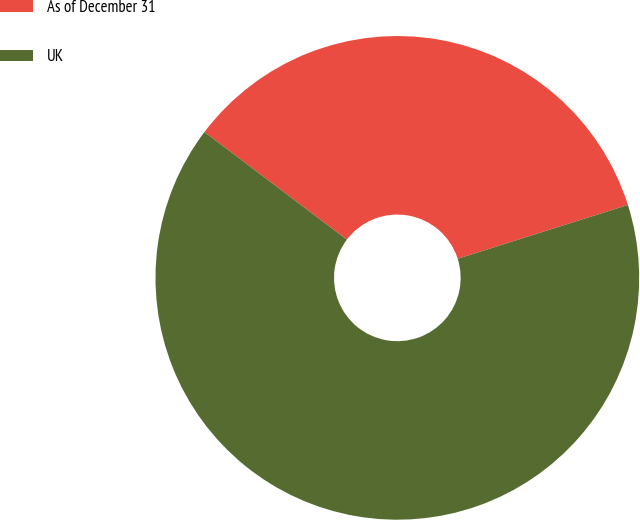Convert chart. <chart><loc_0><loc_0><loc_500><loc_500><pie_chart><fcel>As of December 31<fcel>UK<nl><fcel>34.82%<fcel>65.18%<nl></chart> 